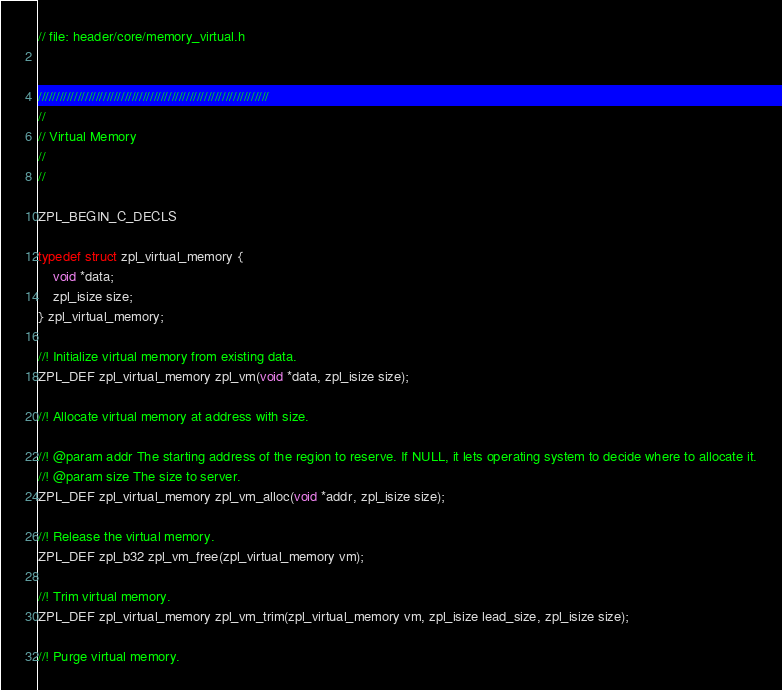Convert code to text. <code><loc_0><loc_0><loc_500><loc_500><_C_>// file: header/core/memory_virtual.h


////////////////////////////////////////////////////////////////
//
// Virtual Memory
//
//

ZPL_BEGIN_C_DECLS

typedef struct zpl_virtual_memory {
    void *data;
    zpl_isize size;
} zpl_virtual_memory;

//! Initialize virtual memory from existing data.
ZPL_DEF zpl_virtual_memory zpl_vm(void *data, zpl_isize size);

//! Allocate virtual memory at address with size.

//! @param addr The starting address of the region to reserve. If NULL, it lets operating system to decide where to allocate it.
//! @param size The size to server.
ZPL_DEF zpl_virtual_memory zpl_vm_alloc(void *addr, zpl_isize size);

//! Release the virtual memory.
ZPL_DEF zpl_b32 zpl_vm_free(zpl_virtual_memory vm);

//! Trim virtual memory.
ZPL_DEF zpl_virtual_memory zpl_vm_trim(zpl_virtual_memory vm, zpl_isize lead_size, zpl_isize size);

//! Purge virtual memory.</code> 